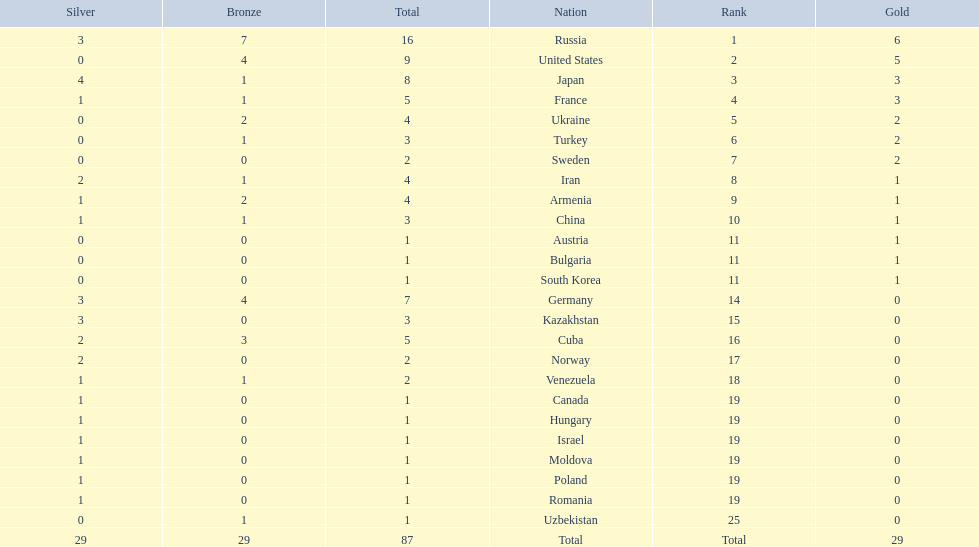What nations have one gold medal? Iran, Armenia, China, Austria, Bulgaria, South Korea. Of these, which nations have zero silver medals? Austria, Bulgaria, South Korea. Of these, which nations also have zero bronze medals? Austria. 